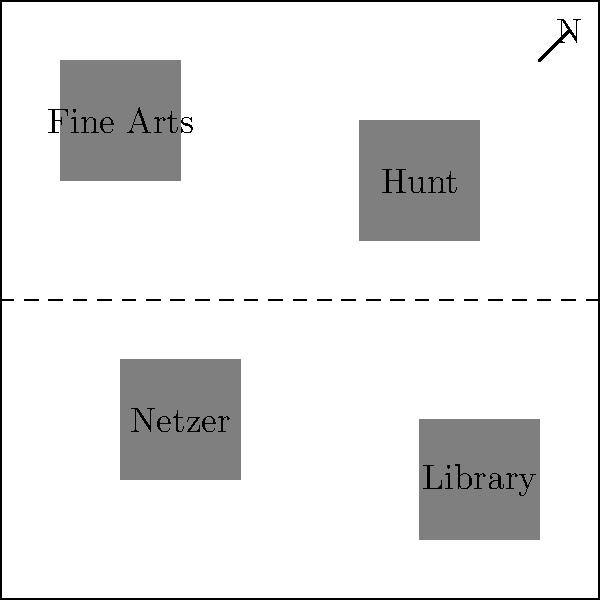Based on the campus map of SUNY Oneonta during the 1970s, which building is located in the southwest quadrant of the campus? To answer this question, let's follow these steps:

1. Understand the map orientation:
   - The "N" in the top right corner indicates that North is in that direction.
   - This means South is towards the bottom of the map, and West is towards the left.

2. Divide the map into quadrants:
   - Imagine a vertical line down the center of the map.
   - Imagine a horizontal line across the center of the map.
   - These lines divide the map into four quadrants.

3. Identify the southwest quadrant:
   - This would be the bottom left quadrant of the map.

4. Examine the buildings in the southwest quadrant:
   - There is only one building located in this area.
   - The building is labeled "Library".

Therefore, the building located in the southwest quadrant of the SUNY Oneonta campus during the 1970s is the Library.
Answer: Library 